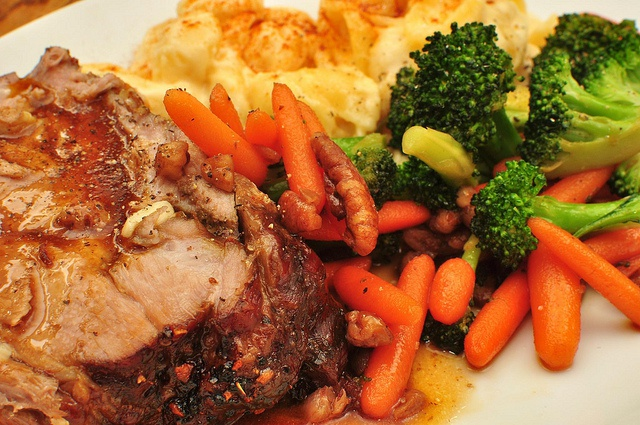Describe the objects in this image and their specific colors. I can see broccoli in brown, olive, and black tones, broccoli in brown, black, darkgreen, and olive tones, broccoli in brown, black, darkgreen, and olive tones, carrot in brown, red, and orange tones, and carrot in brown, red, and orange tones in this image. 